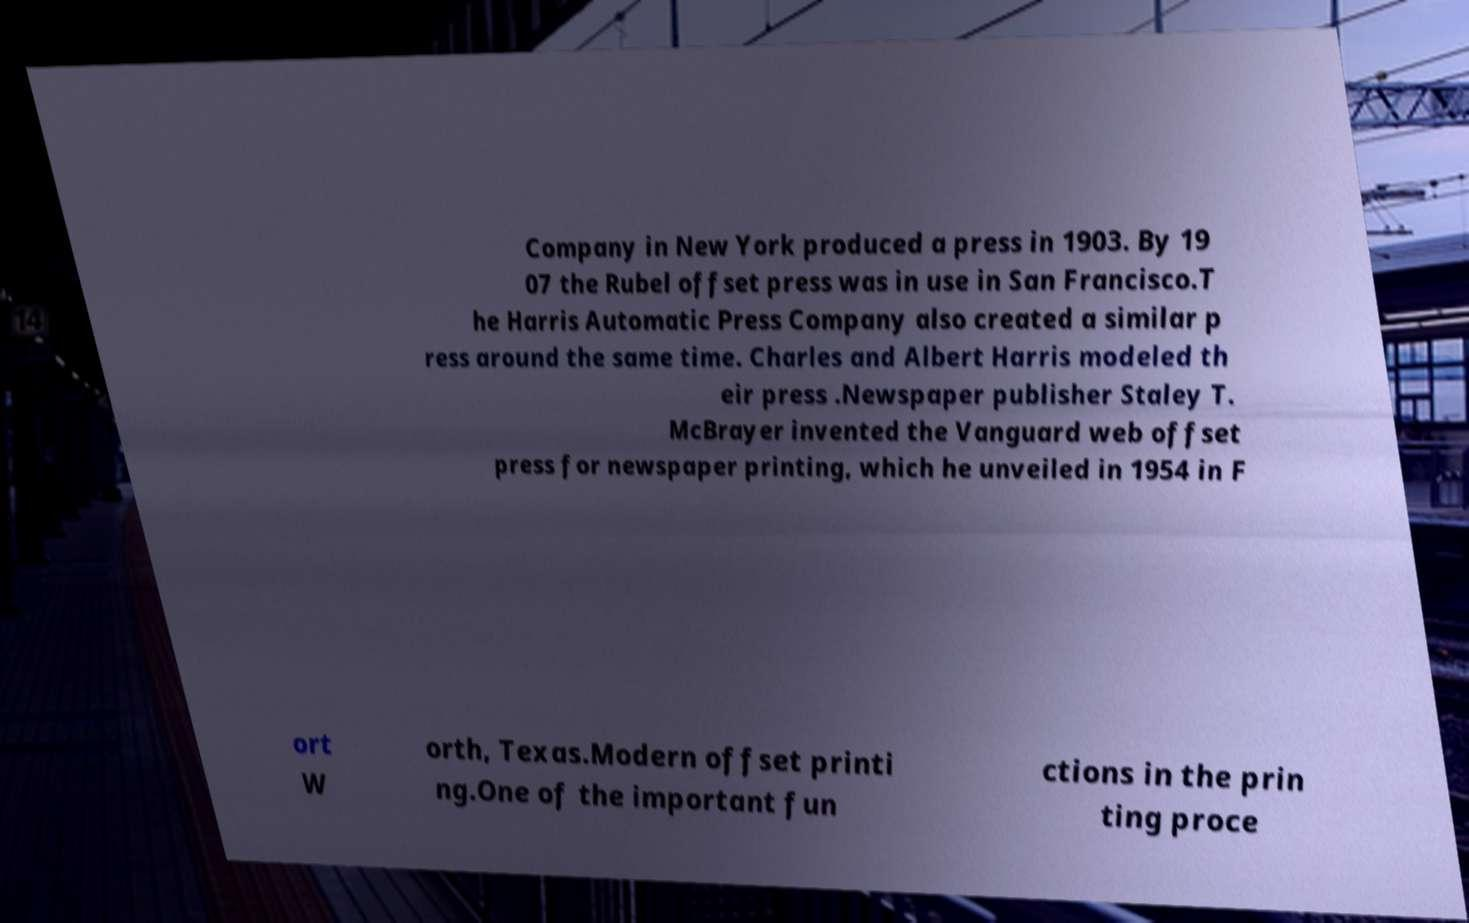Can you read and provide the text displayed in the image?This photo seems to have some interesting text. Can you extract and type it out for me? Company in New York produced a press in 1903. By 19 07 the Rubel offset press was in use in San Francisco.T he Harris Automatic Press Company also created a similar p ress around the same time. Charles and Albert Harris modeled th eir press .Newspaper publisher Staley T. McBrayer invented the Vanguard web offset press for newspaper printing, which he unveiled in 1954 in F ort W orth, Texas.Modern offset printi ng.One of the important fun ctions in the prin ting proce 